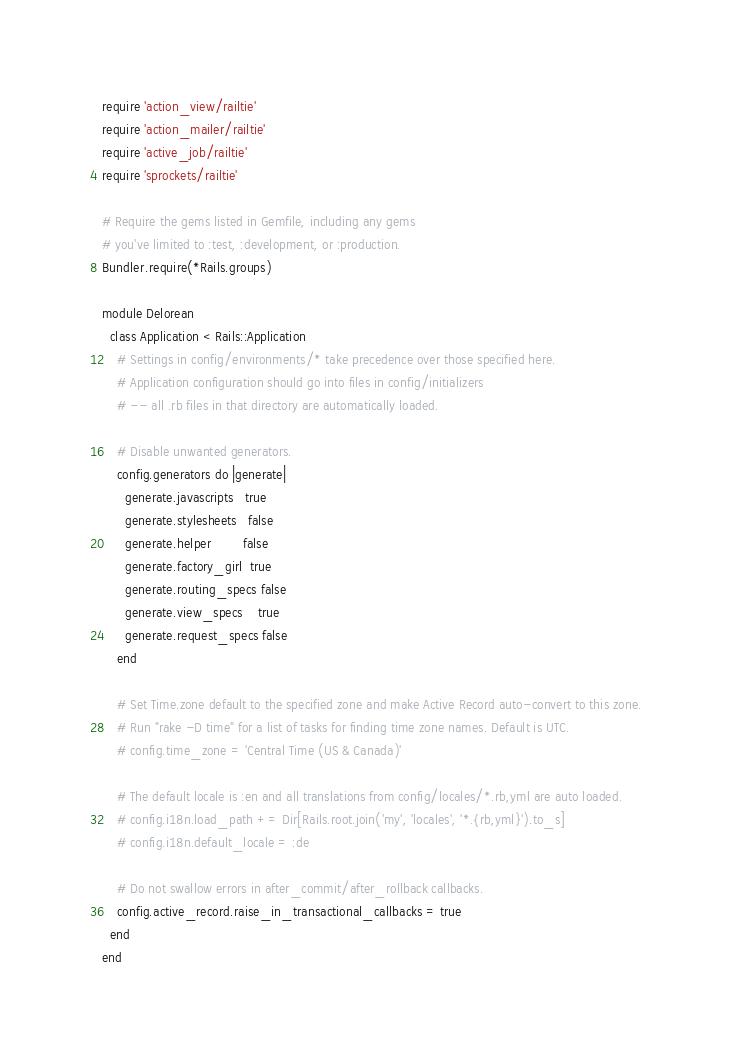Convert code to text. <code><loc_0><loc_0><loc_500><loc_500><_Ruby_>require 'action_view/railtie'
require 'action_mailer/railtie'
require 'active_job/railtie'
require 'sprockets/railtie'

# Require the gems listed in Gemfile, including any gems
# you've limited to :test, :development, or :production.
Bundler.require(*Rails.groups)

module Delorean
  class Application < Rails::Application
    # Settings in config/environments/* take precedence over those specified here.
    # Application configuration should go into files in config/initializers
    # -- all .rb files in that directory are automatically loaded.

    # Disable unwanted generators.
    config.generators do |generate|
      generate.javascripts   true
      generate.stylesheets   false
      generate.helper        false
      generate.factory_girl  true
      generate.routing_specs false
      generate.view_specs    true
      generate.request_specs false
    end

    # Set Time.zone default to the specified zone and make Active Record auto-convert to this zone.
    # Run "rake -D time" for a list of tasks for finding time zone names. Default is UTC.
    # config.time_zone = 'Central Time (US & Canada)'

    # The default locale is :en and all translations from config/locales/*.rb,yml are auto loaded.
    # config.i18n.load_path += Dir[Rails.root.join('my', 'locales', '*.{rb,yml}').to_s]
    # config.i18n.default_locale = :de

    # Do not swallow errors in after_commit/after_rollback callbacks.
    config.active_record.raise_in_transactional_callbacks = true
  end
end
</code> 